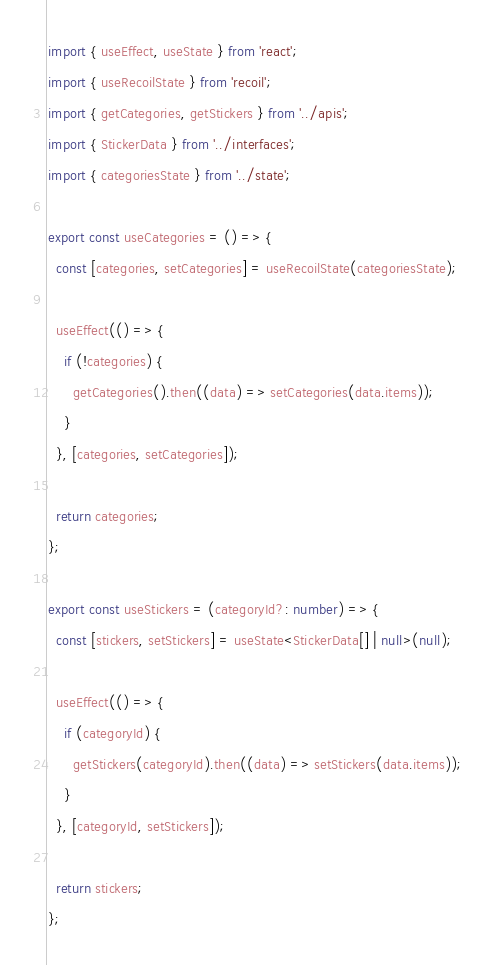Convert code to text. <code><loc_0><loc_0><loc_500><loc_500><_TypeScript_>import { useEffect, useState } from 'react';
import { useRecoilState } from 'recoil';
import { getCategories, getStickers } from '../apis';
import { StickerData } from '../interfaces';
import { categoriesState } from '../state';

export const useCategories = () => {
  const [categories, setCategories] = useRecoilState(categoriesState);

  useEffect(() => {
    if (!categories) {
      getCategories().then((data) => setCategories(data.items));
    }
  }, [categories, setCategories]);

  return categories;
};

export const useStickers = (categoryId?: number) => {
  const [stickers, setStickers] = useState<StickerData[] | null>(null);

  useEffect(() => {
    if (categoryId) {
      getStickers(categoryId).then((data) => setStickers(data.items));
    }
  }, [categoryId, setStickers]);

  return stickers;
};
</code> 